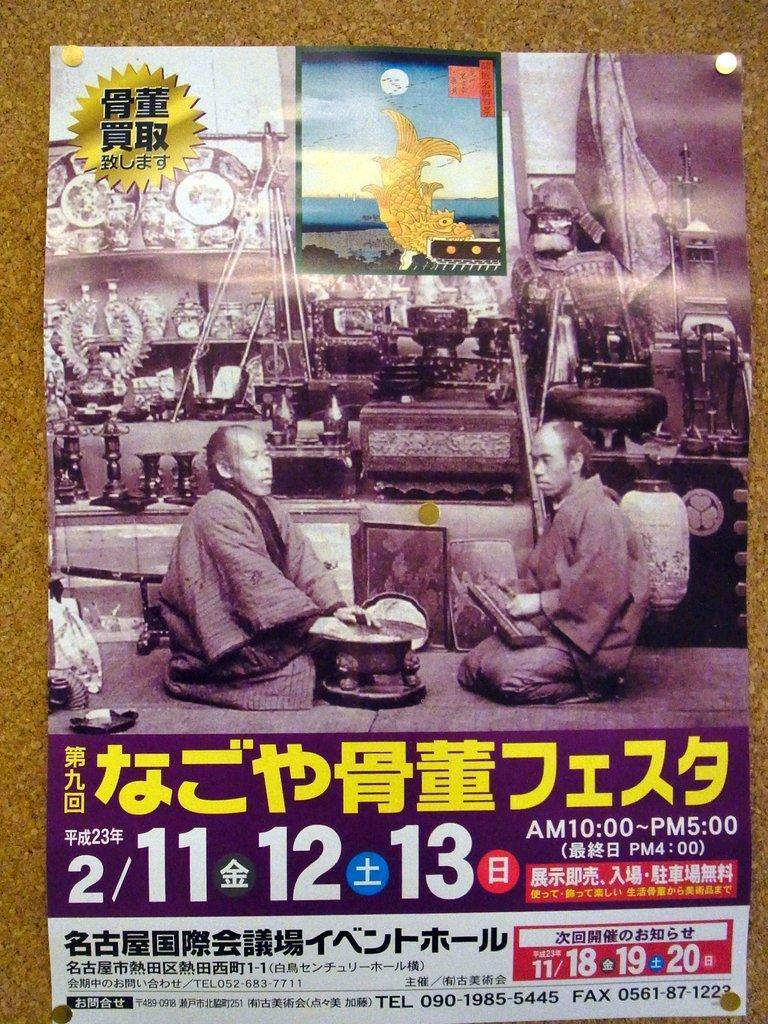In one or two sentences, can you explain what this image depicts? In this picture there is a poster. In the poster there is a picture of a two persons and there are objects on the table and there is a fish, at the bottom of the poster there is a text. There are four push pins at the four ends of the poster. 